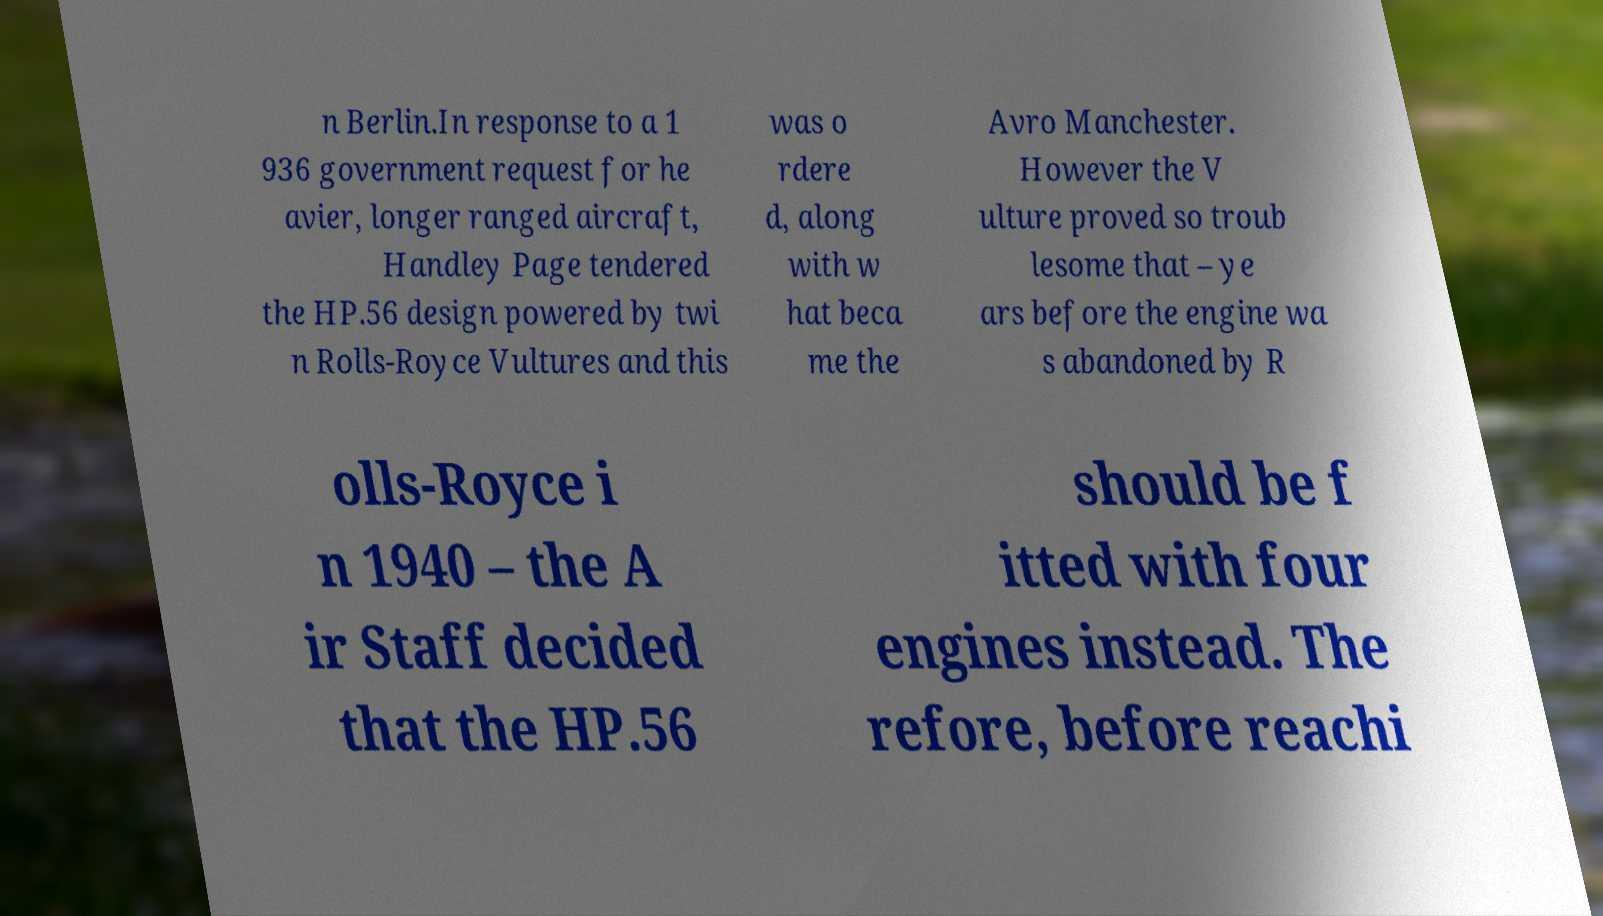For documentation purposes, I need the text within this image transcribed. Could you provide that? n Berlin.In response to a 1 936 government request for he avier, longer ranged aircraft, Handley Page tendered the HP.56 design powered by twi n Rolls-Royce Vultures and this was o rdere d, along with w hat beca me the Avro Manchester. However the V ulture proved so troub lesome that – ye ars before the engine wa s abandoned by R olls-Royce i n 1940 – the A ir Staff decided that the HP.56 should be f itted with four engines instead. The refore, before reachi 